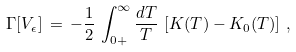Convert formula to latex. <formula><loc_0><loc_0><loc_500><loc_500>\Gamma [ V _ { \epsilon } ] \, = \, - \frac { 1 } { 2 } \, \int _ { 0 + } ^ { \infty } \frac { d T } { T } \, \left [ K ( T ) - K _ { 0 } ( T ) \right ] \, ,</formula> 